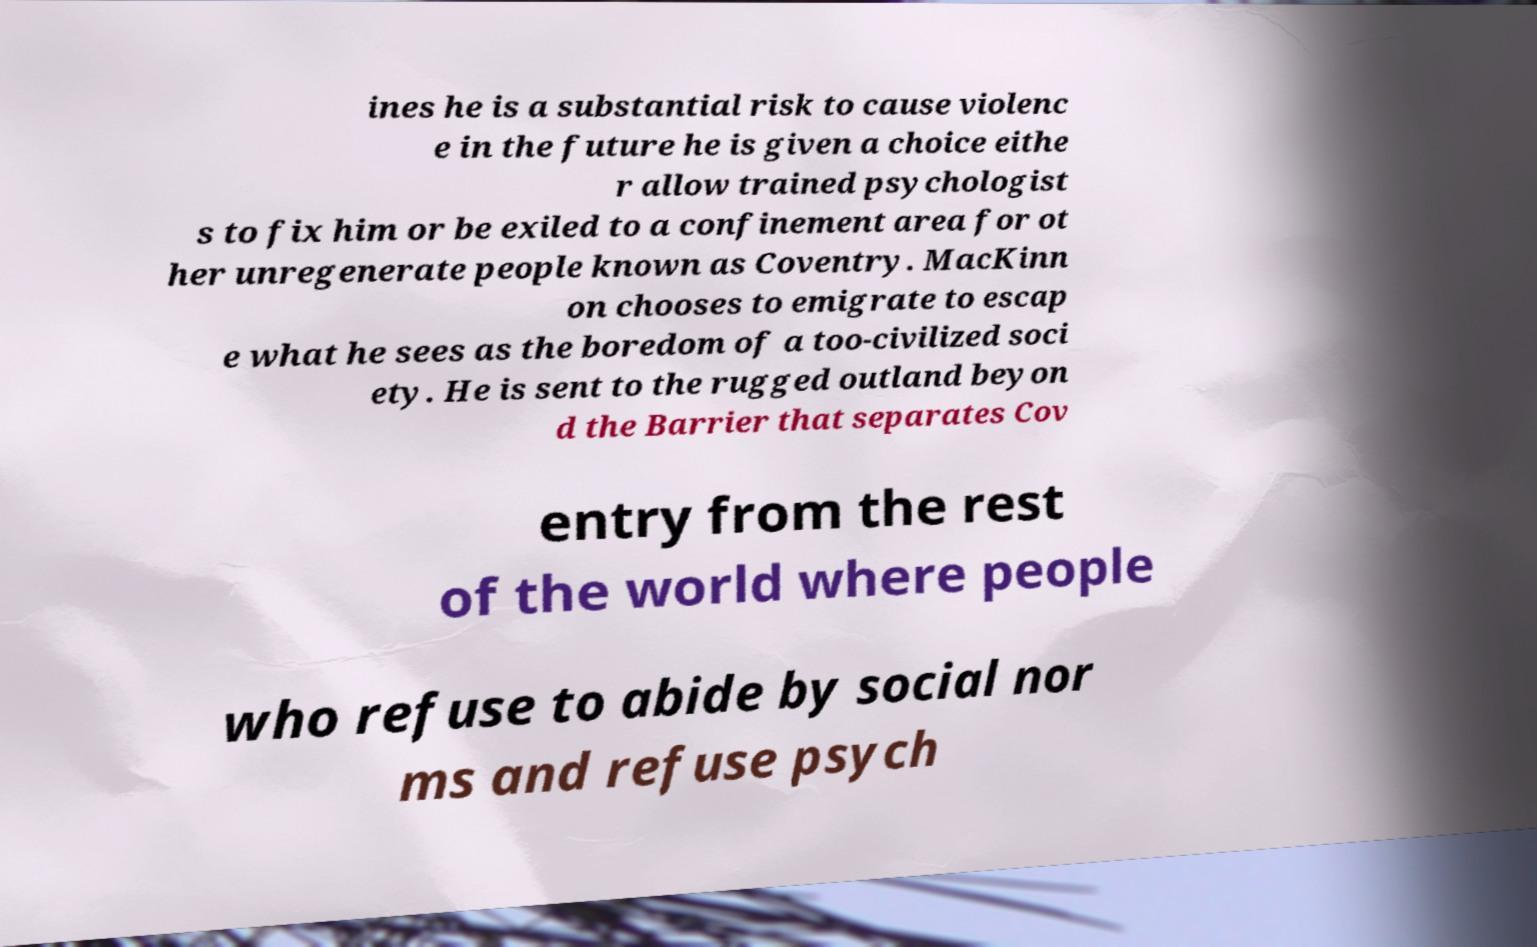Can you read and provide the text displayed in the image?This photo seems to have some interesting text. Can you extract and type it out for me? ines he is a substantial risk to cause violenc e in the future he is given a choice eithe r allow trained psychologist s to fix him or be exiled to a confinement area for ot her unregenerate people known as Coventry. MacKinn on chooses to emigrate to escap e what he sees as the boredom of a too-civilized soci ety. He is sent to the rugged outland beyon d the Barrier that separates Cov entry from the rest of the world where people who refuse to abide by social nor ms and refuse psych 